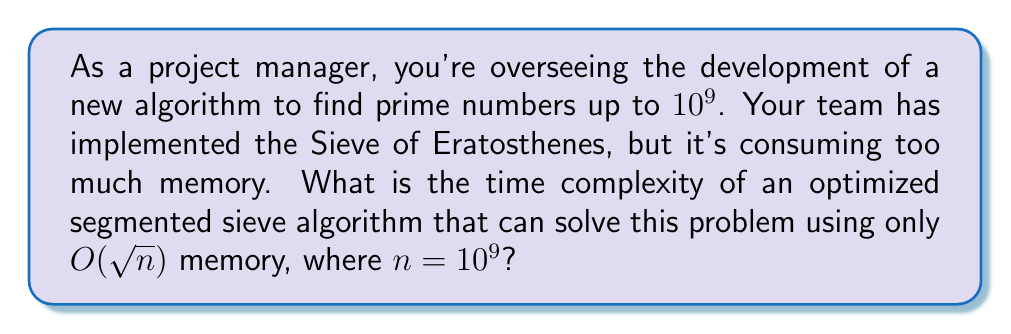Teach me how to tackle this problem. Let's break this down step-by-step:

1) The classical Sieve of Eratosthenes has a time complexity of $O(n \log \log n)$ and space complexity of $O(n)$, which is too memory-intensive for large $n$.

2) The segmented sieve is an optimization that divides the range $[2, n]$ into smaller segments of size $\sqrt{n}$.

3) For each segment:
   a) We first generate primes up to $\sqrt{n}$ using a standard sieve.
   b) We then use these primes to mark composites in the current segment.

4) The time to generate primes up to $\sqrt{n}$ is $O(\sqrt{n} \log \log \sqrt{n})$.

5) For each of the $\frac{n}{\sqrt{n}} = \sqrt{n}$ segments:
   a) We iterate over $O(\pi(\sqrt{n}))$ primes, where $\pi(x)$ is the prime counting function.
   b) For each prime, we perform about $\frac{\sqrt{n}}{p}$ operations.

6) The total time for sieving all segments is:

   $$O(\sqrt{n} \cdot \sum_{p \leq \sqrt{n}} \frac{\sqrt{n}}{p})$$

7) The sum $\sum_{p \leq \sqrt{n}} \frac{1}{p}$ is approximately $O(\log \log n)$.

8) Therefore, the time complexity for sieving all segments is:

   $$O(n \log \log n)$$

9) Adding this to the initial sieving time, we get a total time complexity of:

   $$O(n \log \log n + \sqrt{n} \log \log \sqrt{n}) = O(n \log \log n)$$

Thus, the optimized segmented sieve maintains the same time complexity as the original Sieve of Eratosthenes, while reducing the space complexity to $O(\sqrt{n})$.
Answer: $O(n \log \log n)$ 